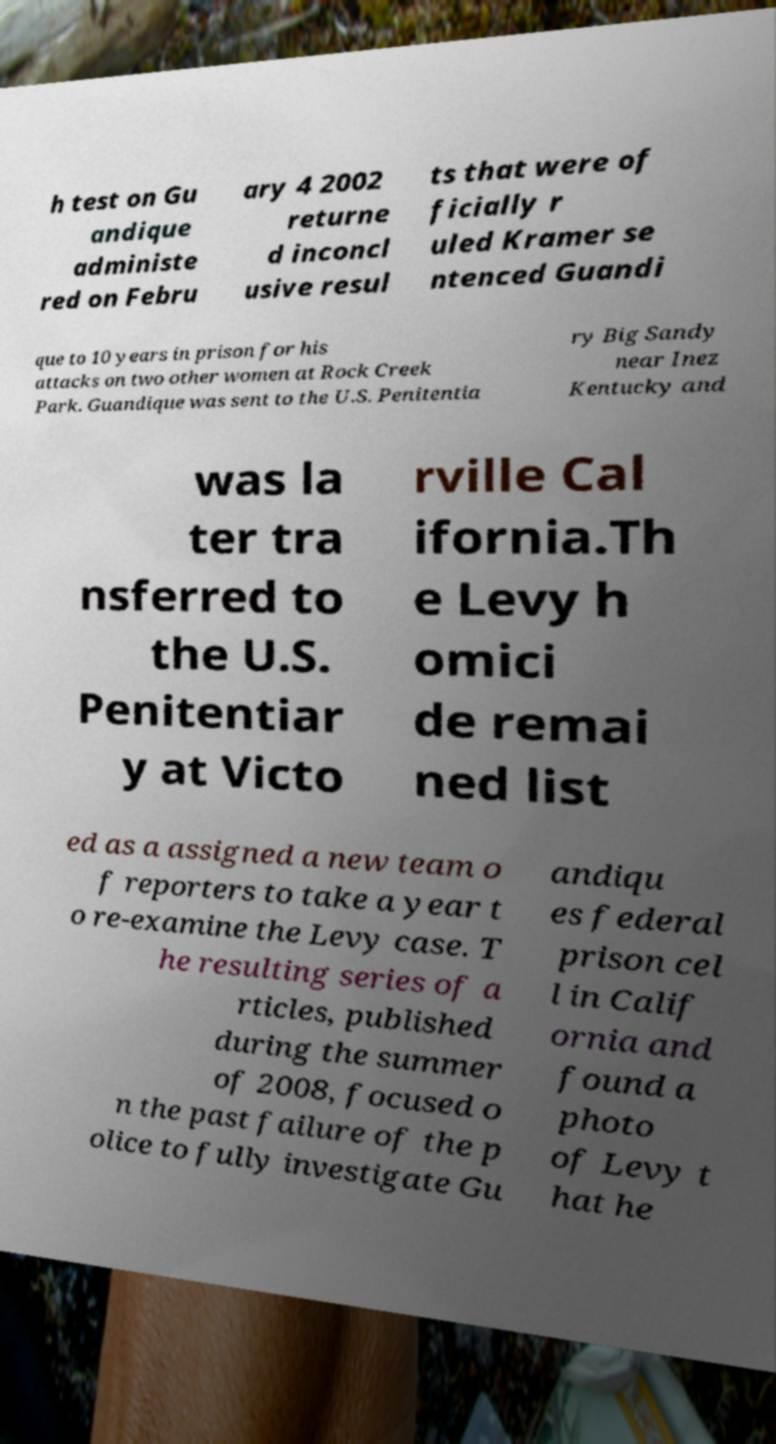What messages or text are displayed in this image? I need them in a readable, typed format. h test on Gu andique administe red on Febru ary 4 2002 returne d inconcl usive resul ts that were of ficially r uled Kramer se ntenced Guandi que to 10 years in prison for his attacks on two other women at Rock Creek Park. Guandique was sent to the U.S. Penitentia ry Big Sandy near Inez Kentucky and was la ter tra nsferred to the U.S. Penitentiar y at Victo rville Cal ifornia.Th e Levy h omici de remai ned list ed as a assigned a new team o f reporters to take a year t o re-examine the Levy case. T he resulting series of a rticles, published during the summer of 2008, focused o n the past failure of the p olice to fully investigate Gu andiqu es federal prison cel l in Calif ornia and found a photo of Levy t hat he 